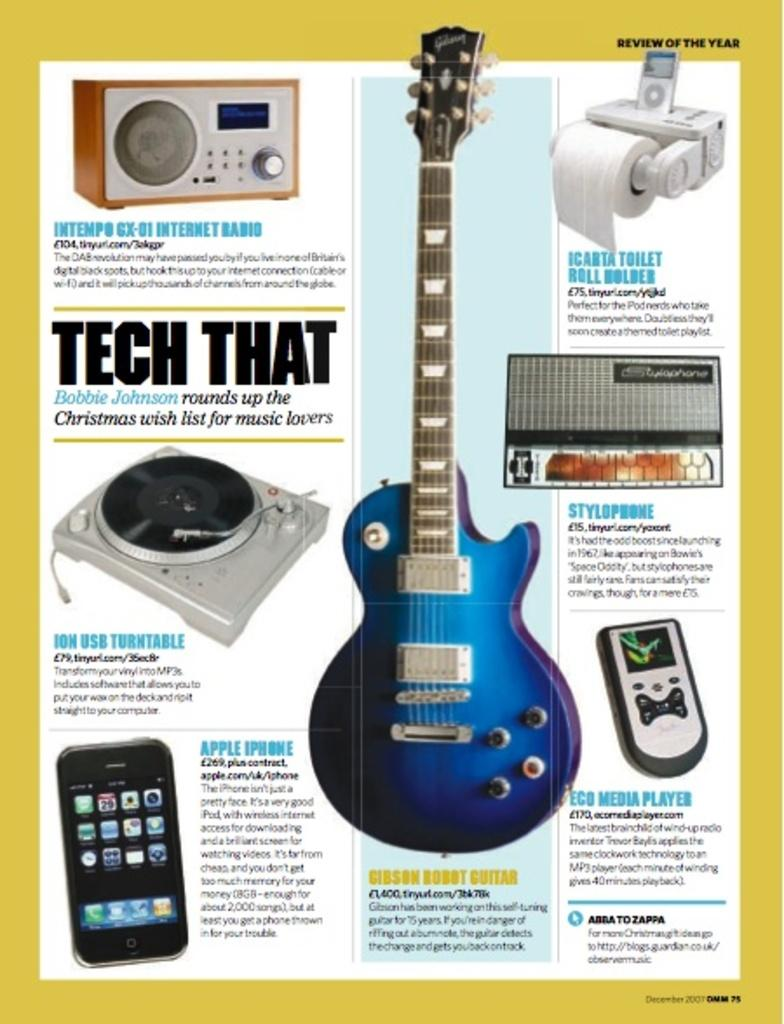<image>
Share a concise interpretation of the image provided. a guitar ad with tech that written on it 